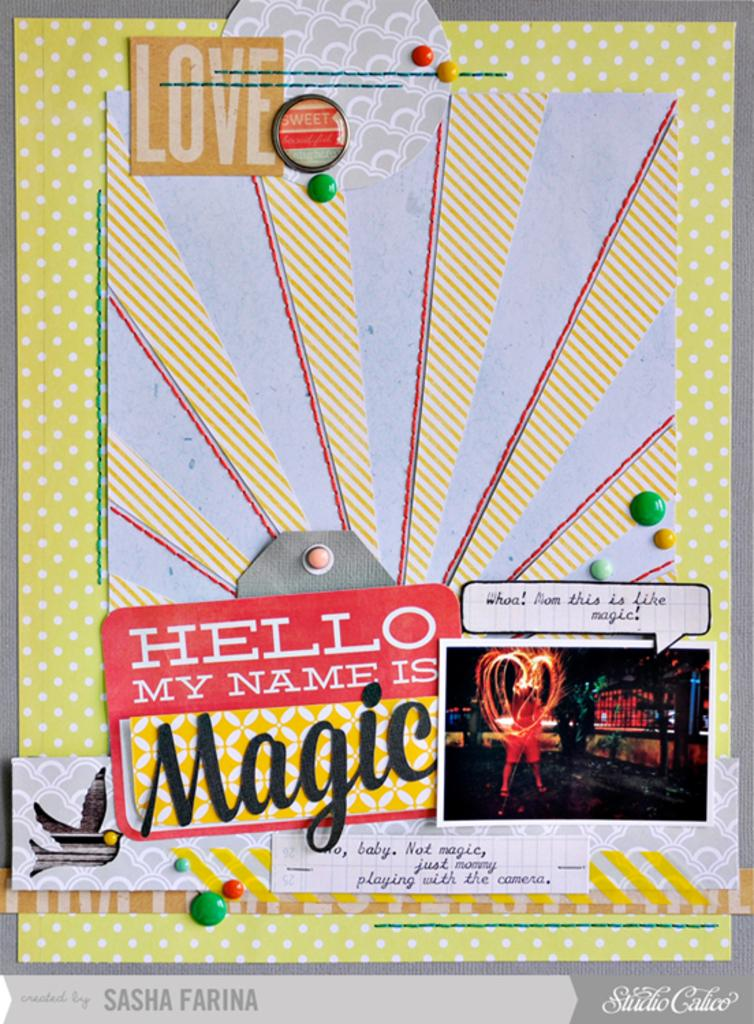<image>
Write a terse but informative summary of the picture. A colorful poster has a name tag that says hello my name is Magic. 